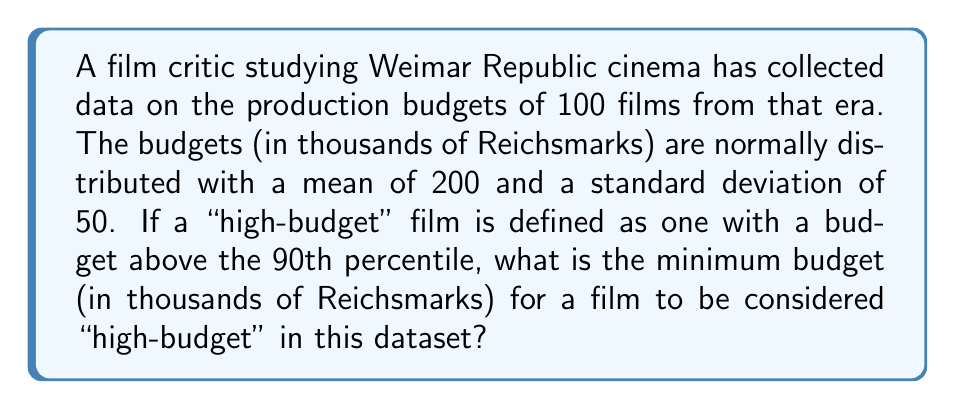Teach me how to tackle this problem. To solve this problem, we need to use the properties of the normal distribution and the concept of z-scores.

1) First, we identify the given information:
   - The distribution is normal
   - Mean ($\mu$) = 200 thousand Reichsmarks
   - Standard deviation ($\sigma$) = 50 thousand Reichsmarks
   - We're looking for the 90th percentile

2) In a normal distribution, percentiles correspond to z-scores. The 90th percentile corresponds to a z-score of 1.28 (this is a standard value that can be found in z-score tables).

3) The formula for a z-score is:

   $$z = \frac{x - \mu}{\sigma}$$

   where $x$ is the value we're looking for, $\mu$ is the mean, and $\sigma$ is the standard deviation.

4) We know the z-score (1.28), $\mu$ (200), and $\sigma$ (50). Let's substitute these into the formula and solve for $x$:

   $$1.28 = \frac{x - 200}{50}$$

5) Multiply both sides by 50:

   $$64 = x - 200$$

6) Add 200 to both sides:

   $$264 = x$$

Therefore, the minimum budget for a "high-budget" film is 264 thousand Reichsmarks.
Answer: 264 thousand Reichsmarks 